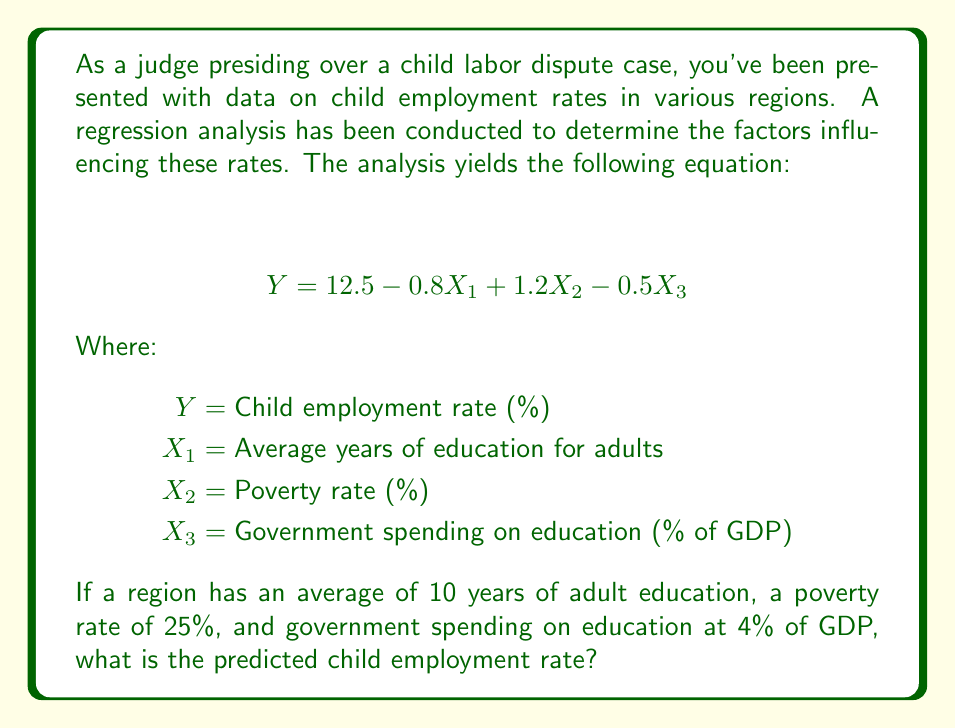Provide a solution to this math problem. To solve this problem, we need to use the given regression equation and substitute the values for each variable. Let's follow these steps:

1. Recall the regression equation:
   $$ Y = 12.5 - 0.8X_1 + 1.2X_2 - 0.5X_3 $$

2. Substitute the given values:
   $X_1 = 10$ (average years of adult education)
   $X_2 = 25$ (poverty rate)
   $X_3 = 4$ (government spending on education as % of GDP)

3. Insert these values into the equation:
   $$ Y = 12.5 - 0.8(10) + 1.2(25) - 0.5(4) $$

4. Solve each term:
   $$ Y = 12.5 - 8 + 30 - 2 $$

5. Perform the arithmetic:
   $$ Y = 32.5 $$

Therefore, the predicted child employment rate for the region with the given characteristics is 32.5%.
Answer: 32.5% 